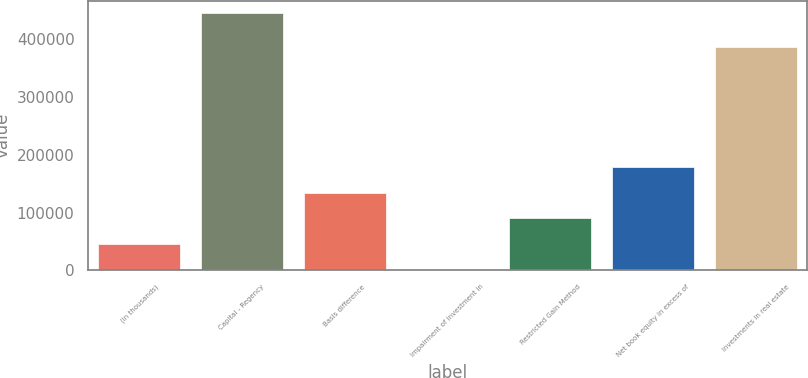Convert chart to OTSL. <chart><loc_0><loc_0><loc_500><loc_500><bar_chart><fcel>(in thousands)<fcel>Capital - Regency<fcel>Basis difference<fcel>Impairment of investment in<fcel>Restricted Gain Method<fcel>Net book equity in excess of<fcel>Investments in real estate<nl><fcel>45676.8<fcel>445068<fcel>134430<fcel>1300<fcel>90053.6<fcel>178807<fcel>386304<nl></chart> 